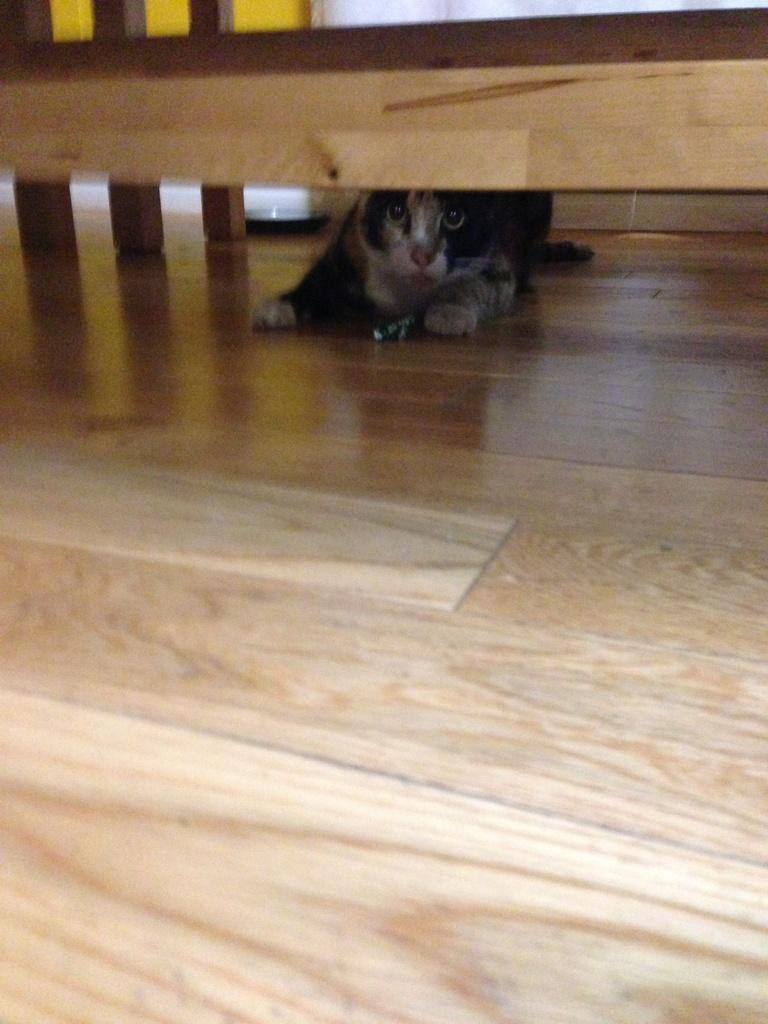What animal is present in the image? There is a duck in the image. Where is the duck located in relation to other objects in the image? The duck is under a wooden block. What type of ink is being used in the office depicted in the image? There is no office or ink present in the image; it features a duck under a wooden block. 